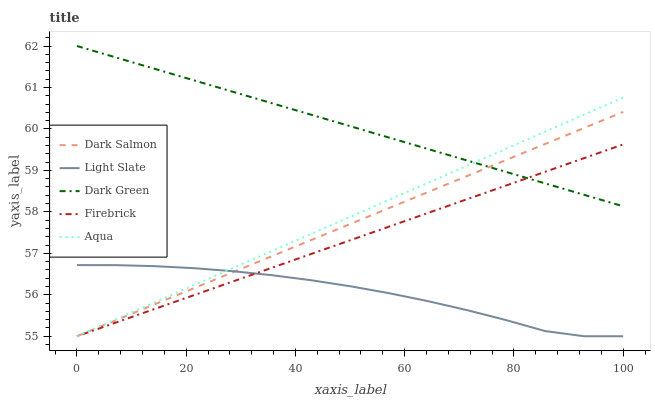Does Light Slate have the minimum area under the curve?
Answer yes or no. Yes. Does Dark Green have the maximum area under the curve?
Answer yes or no. Yes. Does Firebrick have the minimum area under the curve?
Answer yes or no. No. Does Firebrick have the maximum area under the curve?
Answer yes or no. No. Is Aqua the smoothest?
Answer yes or no. Yes. Is Light Slate the roughest?
Answer yes or no. Yes. Is Firebrick the smoothest?
Answer yes or no. No. Is Firebrick the roughest?
Answer yes or no. No. Does Light Slate have the lowest value?
Answer yes or no. Yes. Does Dark Green have the lowest value?
Answer yes or no. No. Does Dark Green have the highest value?
Answer yes or no. Yes. Does Firebrick have the highest value?
Answer yes or no. No. Is Light Slate less than Dark Green?
Answer yes or no. Yes. Is Dark Green greater than Light Slate?
Answer yes or no. Yes. Does Dark Salmon intersect Dark Green?
Answer yes or no. Yes. Is Dark Salmon less than Dark Green?
Answer yes or no. No. Is Dark Salmon greater than Dark Green?
Answer yes or no. No. Does Light Slate intersect Dark Green?
Answer yes or no. No. 